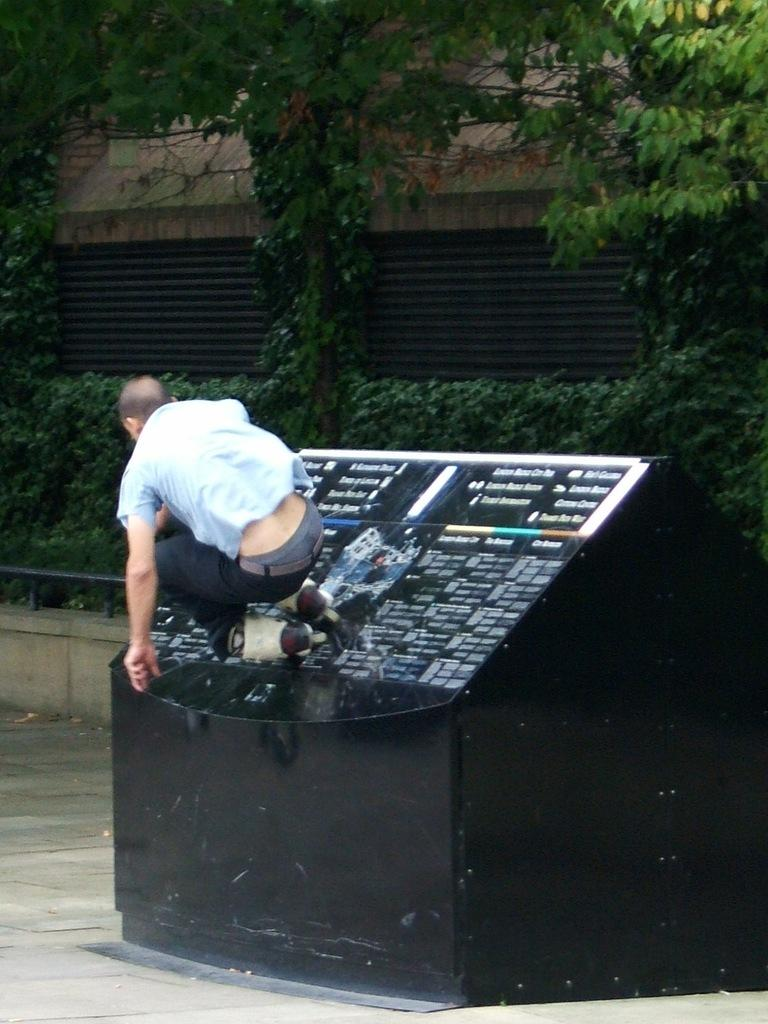Who is present in the image? There is a man in the image. What can be seen in the background of the image? There are trees and a building in the background of the image. What type of gun is the man holding in the image? There is no gun present in the image; the man is not holding any object. 